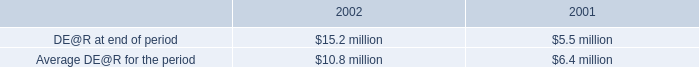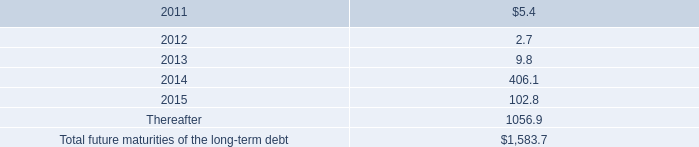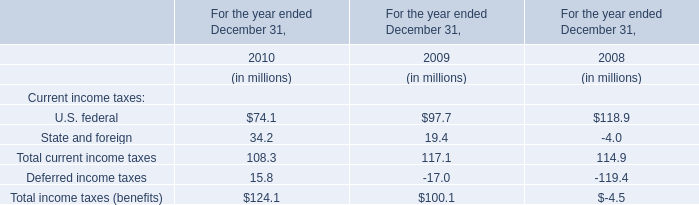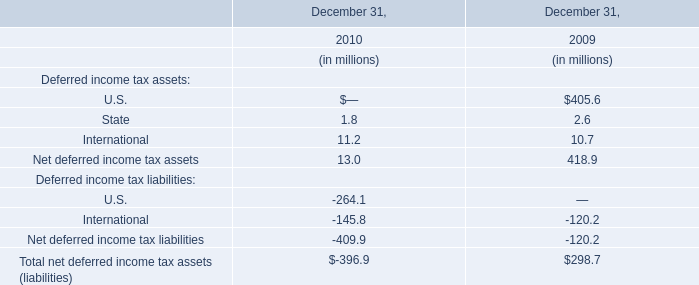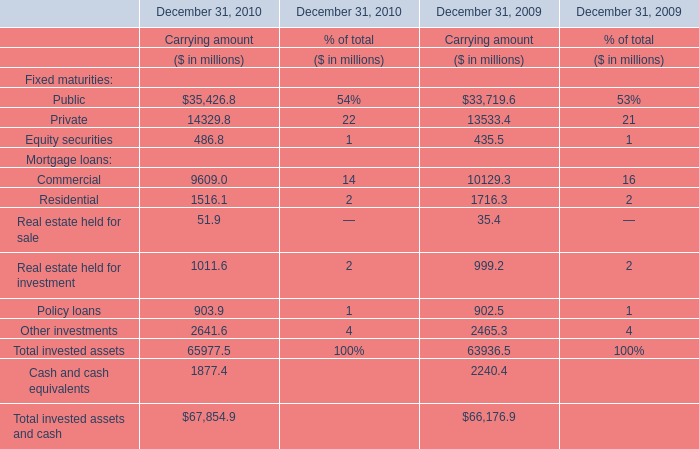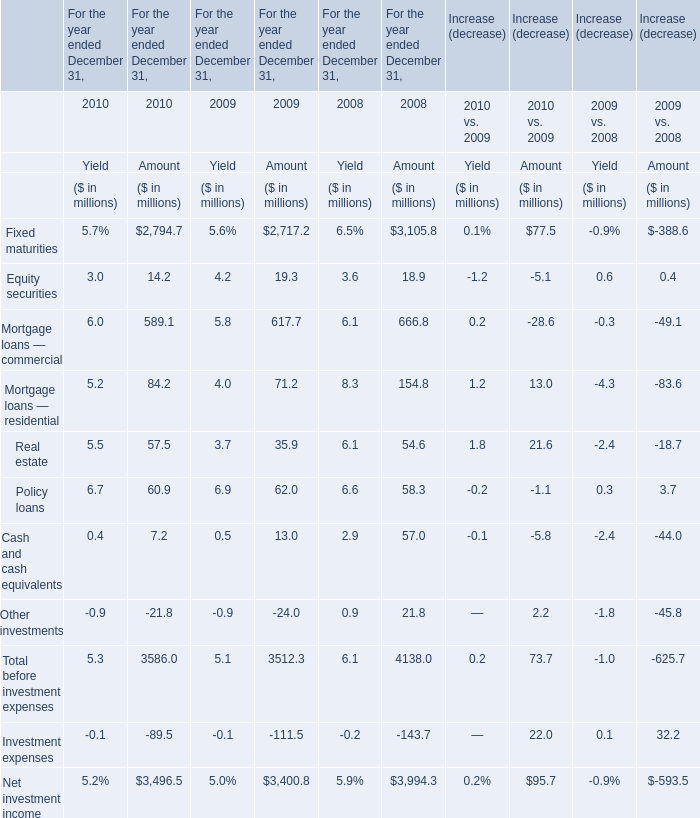If Real estate held for sale develops with the same growth rate in 2010, what will it reach in 2011? (in million) 
Computations: ((((51.9 - 35.4) / 35.4) + 1) * 51.9)
Answer: 76.09068. 